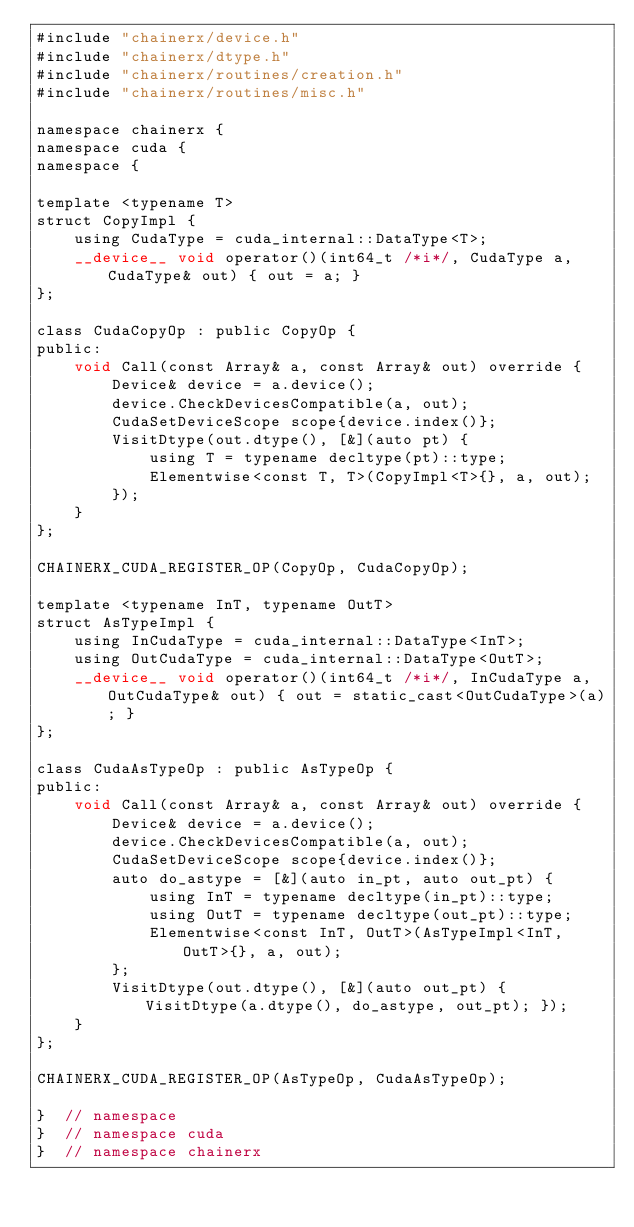Convert code to text. <code><loc_0><loc_0><loc_500><loc_500><_Cuda_>#include "chainerx/device.h"
#include "chainerx/dtype.h"
#include "chainerx/routines/creation.h"
#include "chainerx/routines/misc.h"

namespace chainerx {
namespace cuda {
namespace {

template <typename T>
struct CopyImpl {
    using CudaType = cuda_internal::DataType<T>;
    __device__ void operator()(int64_t /*i*/, CudaType a, CudaType& out) { out = a; }
};

class CudaCopyOp : public CopyOp {
public:
    void Call(const Array& a, const Array& out) override {
        Device& device = a.device();
        device.CheckDevicesCompatible(a, out);
        CudaSetDeviceScope scope{device.index()};
        VisitDtype(out.dtype(), [&](auto pt) {
            using T = typename decltype(pt)::type;
            Elementwise<const T, T>(CopyImpl<T>{}, a, out);
        });
    }
};

CHAINERX_CUDA_REGISTER_OP(CopyOp, CudaCopyOp);

template <typename InT, typename OutT>
struct AsTypeImpl {
    using InCudaType = cuda_internal::DataType<InT>;
    using OutCudaType = cuda_internal::DataType<OutT>;
    __device__ void operator()(int64_t /*i*/, InCudaType a, OutCudaType& out) { out = static_cast<OutCudaType>(a); }
};

class CudaAsTypeOp : public AsTypeOp {
public:
    void Call(const Array& a, const Array& out) override {
        Device& device = a.device();
        device.CheckDevicesCompatible(a, out);
        CudaSetDeviceScope scope{device.index()};
        auto do_astype = [&](auto in_pt, auto out_pt) {
            using InT = typename decltype(in_pt)::type;
            using OutT = typename decltype(out_pt)::type;
            Elementwise<const InT, OutT>(AsTypeImpl<InT, OutT>{}, a, out);
        };
        VisitDtype(out.dtype(), [&](auto out_pt) { VisitDtype(a.dtype(), do_astype, out_pt); });
    }
};

CHAINERX_CUDA_REGISTER_OP(AsTypeOp, CudaAsTypeOp);

}  // namespace
}  // namespace cuda
}  // namespace chainerx
</code> 